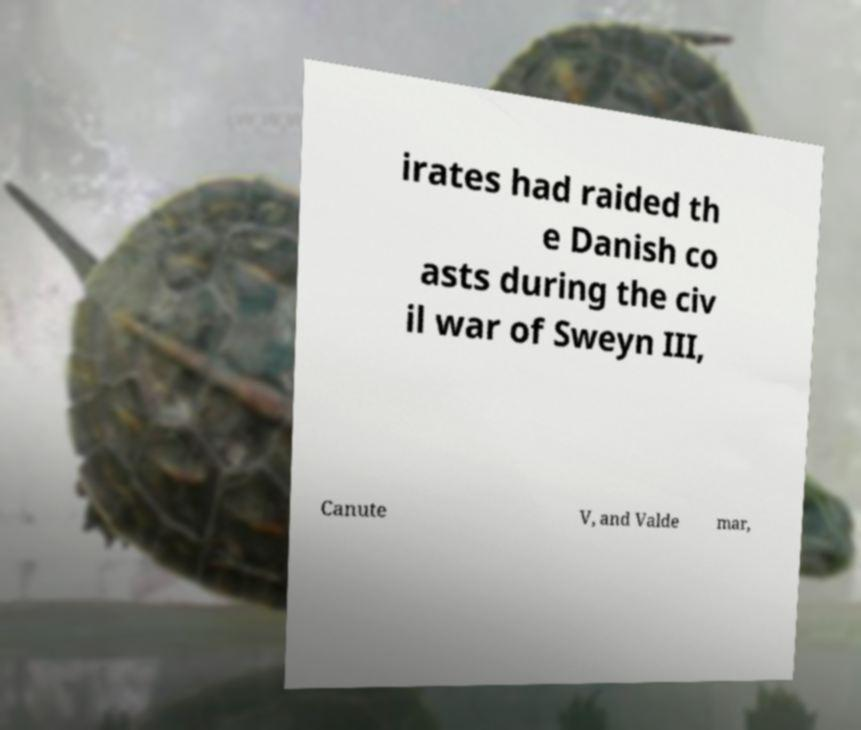Please read and relay the text visible in this image. What does it say? irates had raided th e Danish co asts during the civ il war of Sweyn III, Canute V, and Valde mar, 